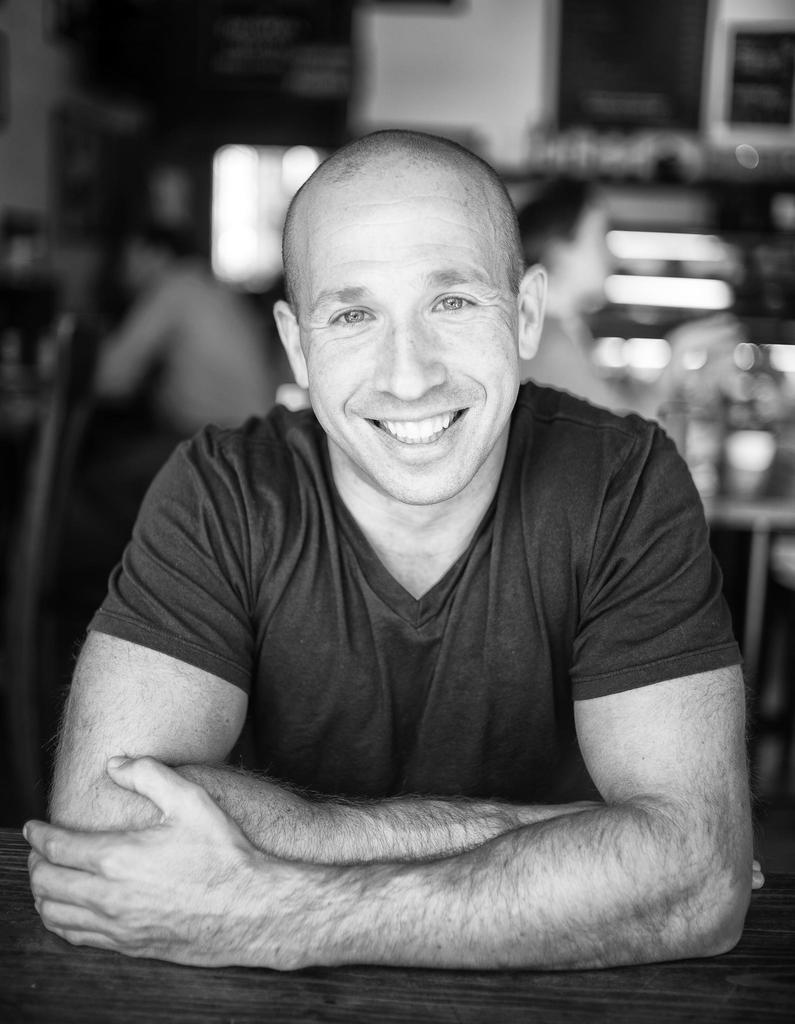What is the color scheme of the image? The image is black and white. Can you describe the person in the image? There is a person in the image, and they are smiling. How would you describe the background of the image? The background of the image is blurred. How many horses are present in the image? There are no horses present in the image; it features a person with a blurred background. What type of arm is visible in the image? There is no specific arm mentioned or visible in the image; it only shows a person smiling. 